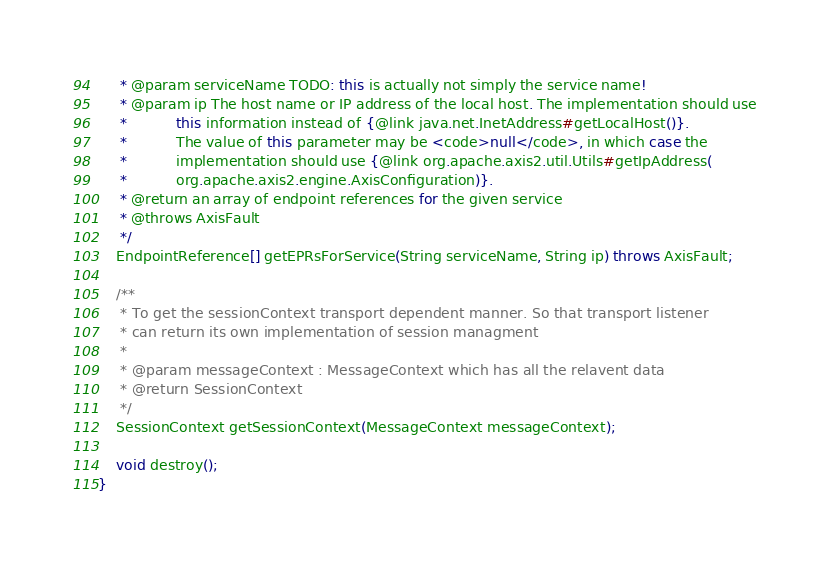Convert code to text. <code><loc_0><loc_0><loc_500><loc_500><_Java_>     * @param serviceName TODO: this is actually not simply the service name!
     * @param ip The host name or IP address of the local host. The implementation should use
     *           this information instead of {@link java.net.InetAddress#getLocalHost()}.
     *           The value of this parameter may be <code>null</code>, in which case the
     *           implementation should use {@link org.apache.axis2.util.Utils#getIpAddress(
     *           org.apache.axis2.engine.AxisConfiguration)}.
     * @return an array of endpoint references for the given service
     * @throws AxisFault
     */
    EndpointReference[] getEPRsForService(String serviceName, String ip) throws AxisFault;

    /**
     * To get the sessionContext transport dependent manner. So that transport listener
     * can return its own implementation of session managment
     *
     * @param messageContext : MessageContext which has all the relavent data
     * @return SessionContext
     */
    SessionContext getSessionContext(MessageContext messageContext);
    
    void destroy();
}
</code> 